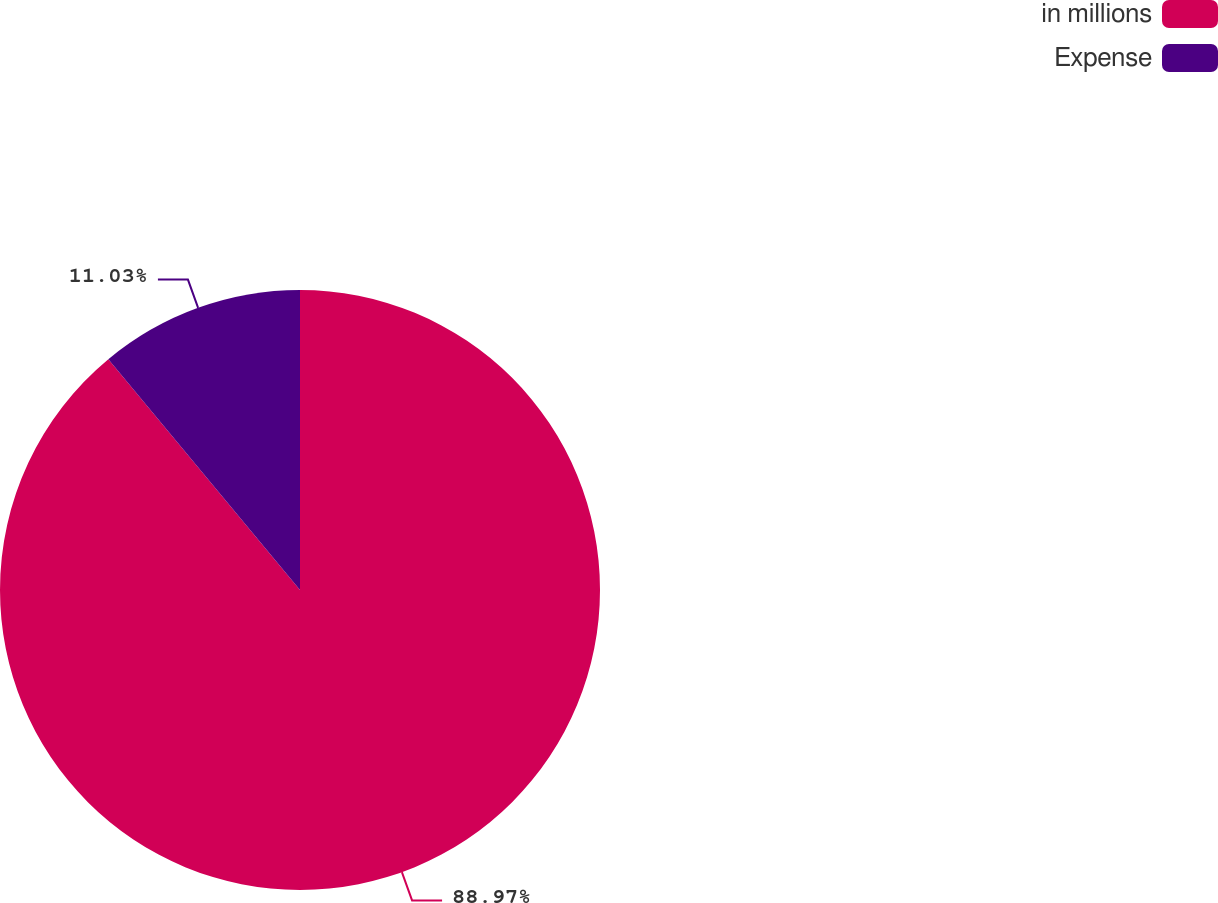Convert chart. <chart><loc_0><loc_0><loc_500><loc_500><pie_chart><fcel>in millions<fcel>Expense<nl><fcel>88.97%<fcel>11.03%<nl></chart> 